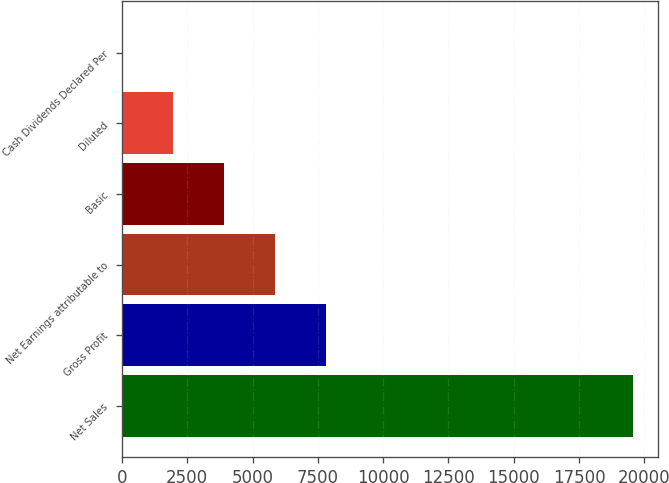<chart> <loc_0><loc_0><loc_500><loc_500><bar_chart><fcel>Net Sales<fcel>Gross Profit<fcel>Net Earnings attributable to<fcel>Basic<fcel>Diluted<fcel>Cash Dividends Declared Per<nl><fcel>19554<fcel>7821.82<fcel>5866.45<fcel>3911.08<fcel>1955.71<fcel>0.34<nl></chart> 